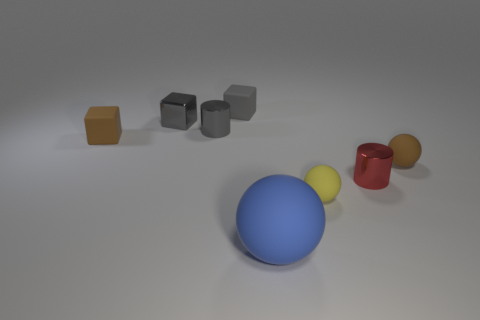There is a metallic cube; does it have the same color as the tiny cylinder left of the large blue object?
Keep it short and to the point. Yes. What size is the blue ball that is the same material as the tiny yellow object?
Your answer should be very brief. Large. Are there any small matte blocks of the same color as the small metallic cube?
Your answer should be very brief. Yes. How many objects are tiny objects in front of the gray cylinder or tiny cylinders?
Keep it short and to the point. 5. Are the tiny red object and the sphere left of the yellow sphere made of the same material?
Give a very brief answer. No. What is the size of the other cube that is the same color as the metal cube?
Your answer should be compact. Small. Are there any yellow balls that have the same material as the tiny brown sphere?
Your answer should be compact. Yes. What number of objects are tiny things that are to the left of the big ball or gray things to the right of the gray metallic cylinder?
Make the answer very short. 4. Is the shape of the gray matte object the same as the small brown thing that is left of the big blue rubber thing?
Offer a terse response. Yes. What number of other objects are the same shape as the tiny red metallic thing?
Offer a very short reply. 1. 